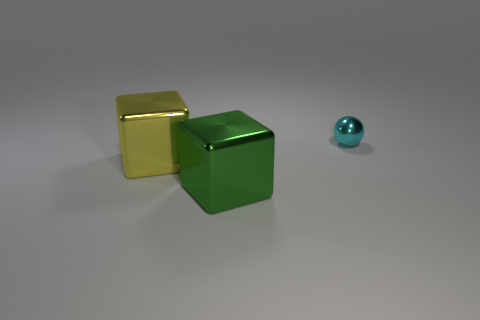Could the arrangement of these objects have any specific meaning? While the arrangement of the objects may not necessarily convey a concrete meaning, it can be interpreted creatively. For instance, they might symbolize balance, with the small cyan ball offsetting the visual weight of the larger cubes, or represent an abstract composition focusing on geometry and color contrast. 